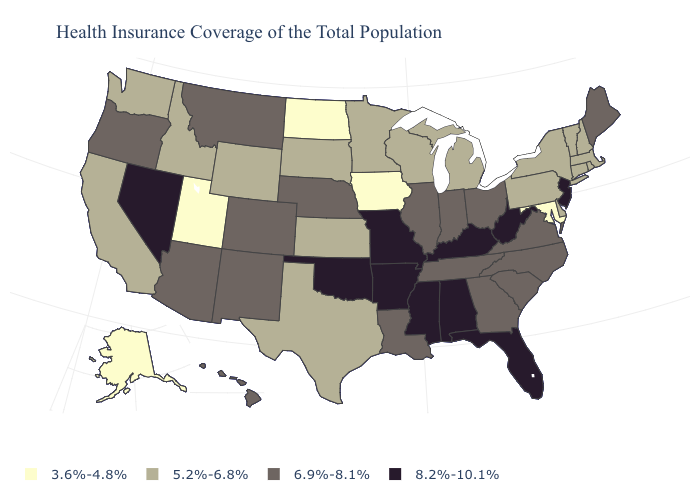Among the states that border Connecticut , which have the highest value?
Quick response, please. Massachusetts, New York, Rhode Island. What is the value of Michigan?
Quick response, please. 5.2%-6.8%. Among the states that border Washington , does Oregon have the highest value?
Quick response, please. Yes. Does the map have missing data?
Be succinct. No. Name the states that have a value in the range 6.9%-8.1%?
Write a very short answer. Arizona, Colorado, Georgia, Hawaii, Illinois, Indiana, Louisiana, Maine, Montana, Nebraska, New Mexico, North Carolina, Ohio, Oregon, South Carolina, Tennessee, Virginia. Which states have the highest value in the USA?
Keep it brief. Alabama, Arkansas, Florida, Kentucky, Mississippi, Missouri, Nevada, New Jersey, Oklahoma, West Virginia. Which states have the highest value in the USA?
Quick response, please. Alabama, Arkansas, Florida, Kentucky, Mississippi, Missouri, Nevada, New Jersey, Oklahoma, West Virginia. How many symbols are there in the legend?
Concise answer only. 4. Does Wisconsin have the lowest value in the USA?
Keep it brief. No. Name the states that have a value in the range 6.9%-8.1%?
Concise answer only. Arizona, Colorado, Georgia, Hawaii, Illinois, Indiana, Louisiana, Maine, Montana, Nebraska, New Mexico, North Carolina, Ohio, Oregon, South Carolina, Tennessee, Virginia. What is the value of Indiana?
Keep it brief. 6.9%-8.1%. Which states hav the highest value in the South?
Write a very short answer. Alabama, Arkansas, Florida, Kentucky, Mississippi, Oklahoma, West Virginia. What is the value of New Jersey?
Be succinct. 8.2%-10.1%. Among the states that border Wyoming , which have the lowest value?
Quick response, please. Utah. 